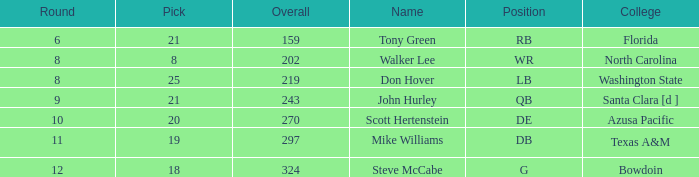What college has an overall less than 243, and tony green as the name? Florida. 